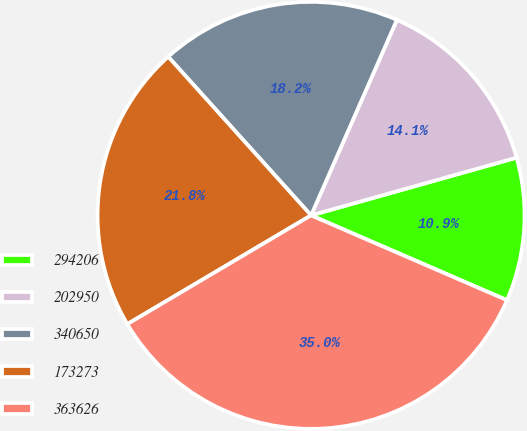Convert chart to OTSL. <chart><loc_0><loc_0><loc_500><loc_500><pie_chart><fcel>294206<fcel>202950<fcel>340650<fcel>173273<fcel>363626<nl><fcel>10.86%<fcel>14.06%<fcel>18.25%<fcel>21.84%<fcel>34.99%<nl></chart> 